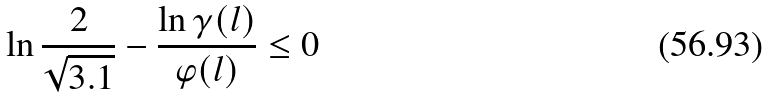<formula> <loc_0><loc_0><loc_500><loc_500>\ln { \frac { 2 } { \sqrt { 3 . 1 } } - \frac { \ln { \gamma ( l ) } } { \varphi ( l ) } } \leq 0</formula> 